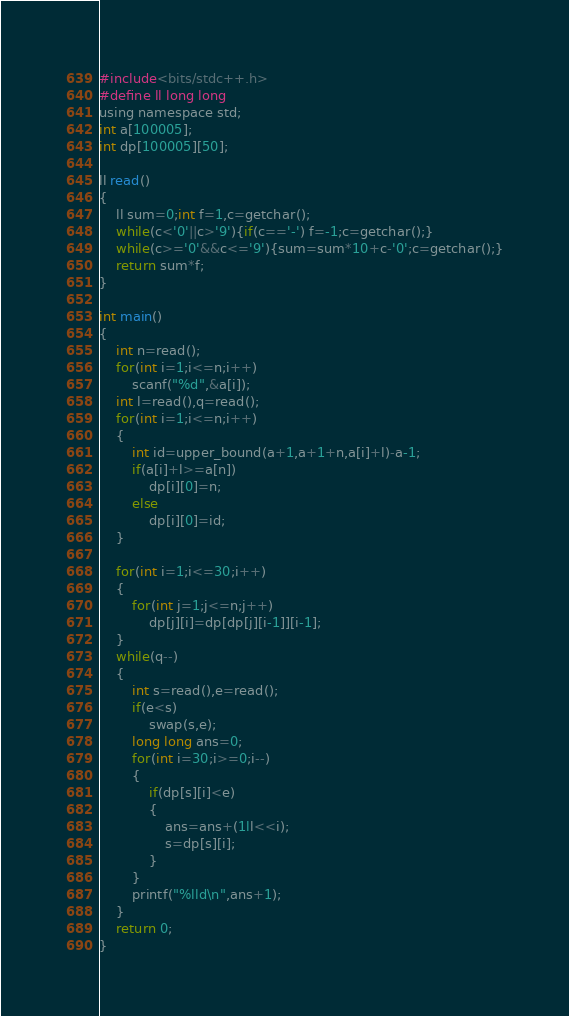Convert code to text. <code><loc_0><loc_0><loc_500><loc_500><_C_>#include<bits/stdc++.h>
#define ll long long
using namespace std;
int a[100005];
int dp[100005][50];

ll read()
{
	ll sum=0;int f=1,c=getchar();
	while(c<'0'||c>'9'){if(c=='-') f=-1;c=getchar();}
	while(c>='0'&&c<='9'){sum=sum*10+c-'0';c=getchar();}
	return sum*f;
}

int main()
{
    int n=read();
    for(int i=1;i<=n;i++)
        scanf("%d",&a[i]);
    int l=read(),q=read();
    for(int i=1;i<=n;i++)
    {
        int id=upper_bound(a+1,a+1+n,a[i]+l)-a-1;
        if(a[i]+l>=a[n])
            dp[i][0]=n;
        else
            dp[i][0]=id;
    }
     
    for(int i=1;i<=30;i++)
    {
        for(int j=1;j<=n;j++)
            dp[j][i]=dp[dp[j][i-1]][i-1];
    }
    while(q--)
    {
        int s=read(),e=read();
        if(e<s)
            swap(s,e);  
        long long ans=0;
        for(int i=30;i>=0;i--)
        {
            if(dp[s][i]<e)
            {
                ans=ans+(1ll<<i);
                s=dp[s][i];
            }
        }
        printf("%lld\n",ans+1);
    }
    return 0;
}</code> 